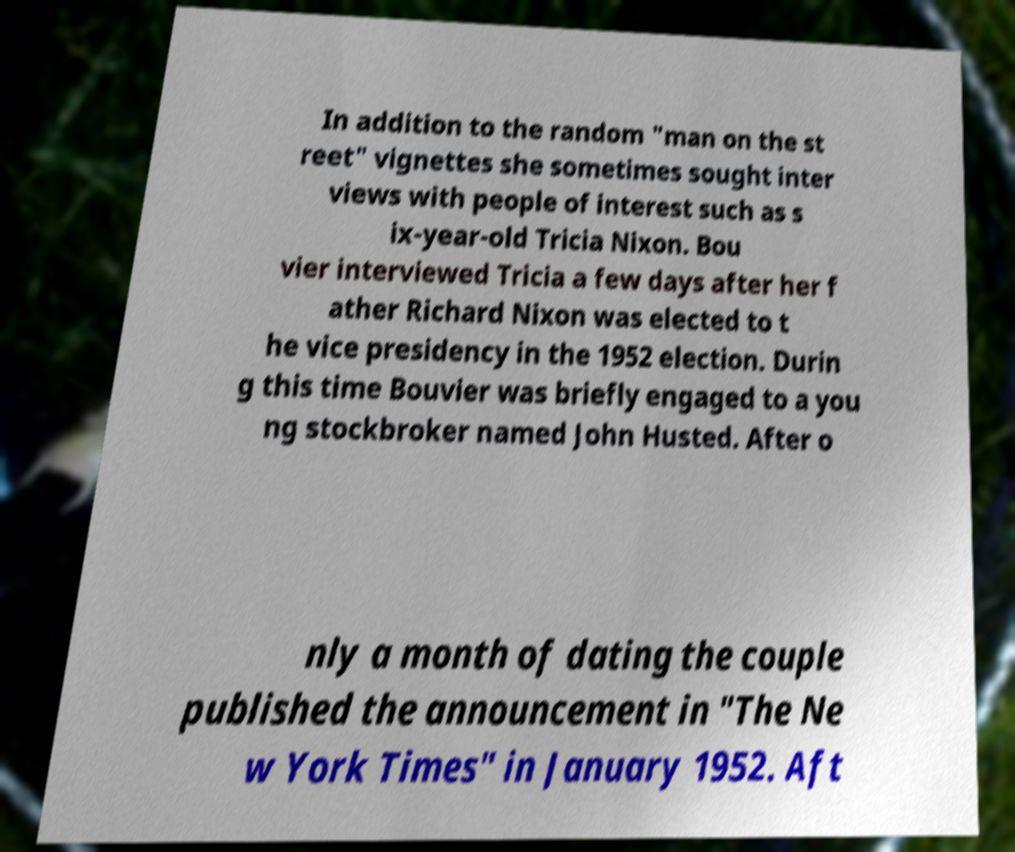Please identify and transcribe the text found in this image. In addition to the random "man on the st reet" vignettes she sometimes sought inter views with people of interest such as s ix-year-old Tricia Nixon. Bou vier interviewed Tricia a few days after her f ather Richard Nixon was elected to t he vice presidency in the 1952 election. Durin g this time Bouvier was briefly engaged to a you ng stockbroker named John Husted. After o nly a month of dating the couple published the announcement in "The Ne w York Times" in January 1952. Aft 